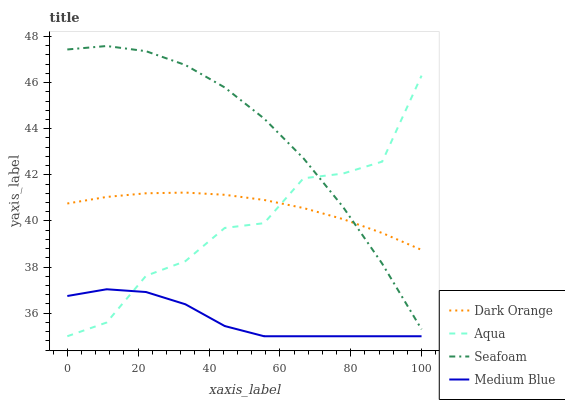Does Medium Blue have the minimum area under the curve?
Answer yes or no. Yes. Does Seafoam have the maximum area under the curve?
Answer yes or no. Yes. Does Dark Orange have the minimum area under the curve?
Answer yes or no. No. Does Dark Orange have the maximum area under the curve?
Answer yes or no. No. Is Dark Orange the smoothest?
Answer yes or no. Yes. Is Aqua the roughest?
Answer yes or no. Yes. Is Aqua the smoothest?
Answer yes or no. No. Is Dark Orange the roughest?
Answer yes or no. No. Does Medium Blue have the lowest value?
Answer yes or no. Yes. Does Dark Orange have the lowest value?
Answer yes or no. No. Does Seafoam have the highest value?
Answer yes or no. Yes. Does Dark Orange have the highest value?
Answer yes or no. No. Is Medium Blue less than Dark Orange?
Answer yes or no. Yes. Is Dark Orange greater than Medium Blue?
Answer yes or no. Yes. Does Medium Blue intersect Aqua?
Answer yes or no. Yes. Is Medium Blue less than Aqua?
Answer yes or no. No. Is Medium Blue greater than Aqua?
Answer yes or no. No. Does Medium Blue intersect Dark Orange?
Answer yes or no. No. 